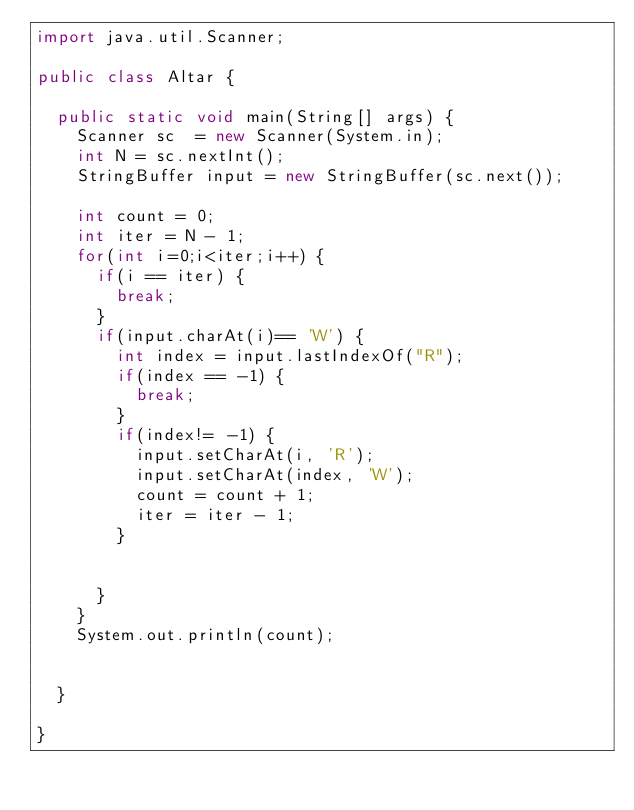Convert code to text. <code><loc_0><loc_0><loc_500><loc_500><_Java_>import java.util.Scanner;

public class Altar {

	public static void main(String[] args) {
		Scanner sc  = new Scanner(System.in);
		int N = sc.nextInt();
		StringBuffer input = new StringBuffer(sc.next());
	
		int count = 0;
		int iter = N - 1;
		for(int i=0;i<iter;i++) {
			if(i == iter) {
				break;
			}
			if(input.charAt(i)== 'W') {
				int index = input.lastIndexOf("R");
				if(index == -1) {
					break;
				}
				if(index!= -1) {
					input.setCharAt(i, 'R');
					input.setCharAt(index, 'W');
					count = count + 1;
					iter = iter - 1;
				}
				
				
			}
		}
		System.out.println(count);
		

	}

}
</code> 